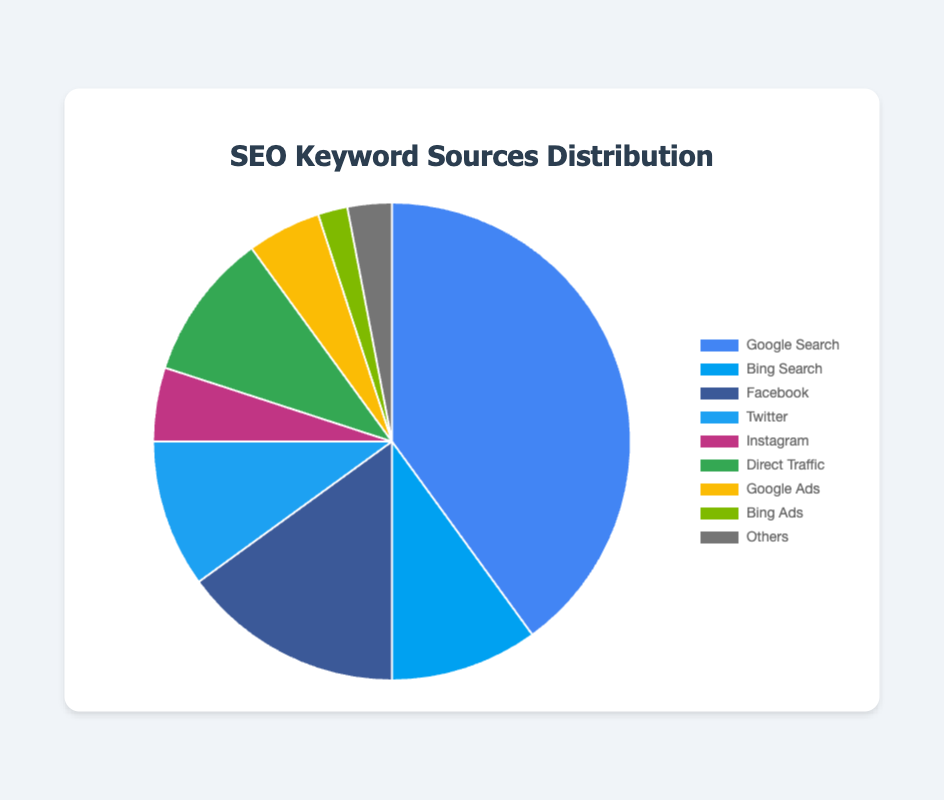How much larger is the percentage of keywords from Google Search compared to Bing Search? The Google Search percentage is 40% and Bing Search is 10%. The difference between them is 40% - 10% = 30%.
Answer: 30% Which keyword source has the smallest percentage and what is that percentage? By examining the pie chart, Bing Ads has the smallest segment. The corresponding percentage for Bing Ads is 2%.
Answer: Bing Ads, 2% What combined percentage do the social media sources (Facebook, Twitter, Instagram) contribute to the total? The percentages are Facebook (15%), Twitter (10%), and Instagram (5%). Adding these numbers gives 15% + 10% + 5% = 30%.
Answer: 30% Is the percentage of keywords from Direct Traffic greater than that from Paid Ads (Google Ads and Bing Ads combined)? The percentage for Direct Traffic is 10%. The combined percentage for Google Ads (5%) and Bing Ads (2%) is 5% + 2% = 7%. Thus, 10% (Direct Traffic) is greater than 7% (Paid Ads).
Answer: Yes Which sources contribute 10% each to the total keyword sources? From the pie chart, both Bing Search and Twitter have segments labeled with 10%.
Answer: Bing Search, Twitter What is the total percentage shared by Google Search and Others? The percentages are 40% for Google Search and 3% for Others. Summing these gives 40% + 3% = 43%.
Answer: 43% If we consider Google Ads, Bing Ads, and Others as a group, what is their combined percentage, and how does it compare to Facebook alone? The percentages for Google Ads, Bing Ads, and Others are 5%, 2%, and 3%, respectively. The combined total is 5% + 2% + 3% = 10%. Facebook alone has a percentage of 15%. Since 10% < 15%, this group is smaller than Facebook alone.
Answer: 10%, less Which source segment is visually highlighted in blue, and what is its associated percentage? Observing the pie chart, the segment visually represented by the color blue corresponds to Google Search. This source has a percentage of 40%.
Answer: Google Search, 40% What is the average percentage of the keyword sources from Bing Ads, Instagram, and Others? The percentages are Bing Ads (2%), Instagram (5%), and Others (3%). The average is calculated as (2% + 5% + 3%) / 3 = 10% / 3 ≈ 3.33%.
Answer: 3.33% How does the total percentage of keywords from social media platforms (Facebook, Twitter, Instagram) compare to the percentage from Google Search? The total percentage from social media platforms is 30% (calculated previously). Google Search alone contributes 40%. Since 30% < 40%, Google Search has a higher percentage.
Answer: Less 